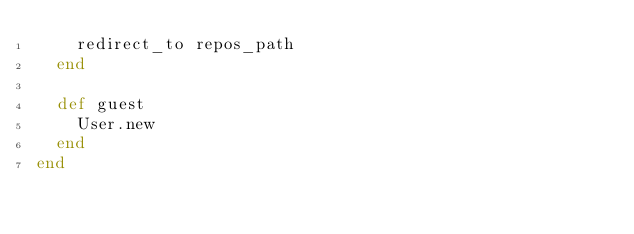<code> <loc_0><loc_0><loc_500><loc_500><_Ruby_>    redirect_to repos_path
  end

  def guest
    User.new
  end
end
</code> 